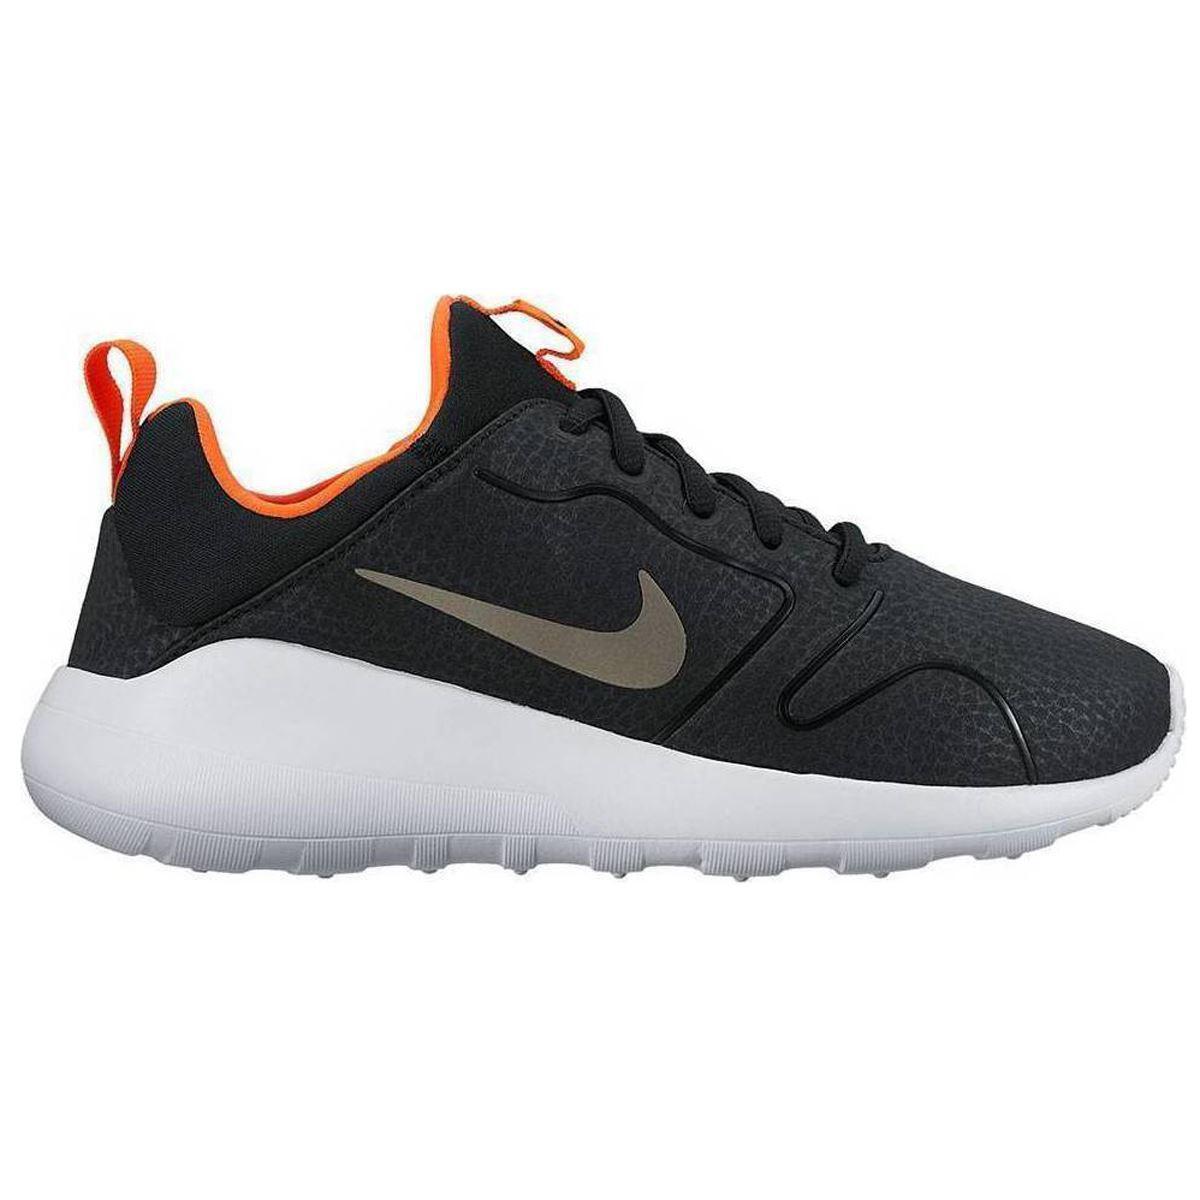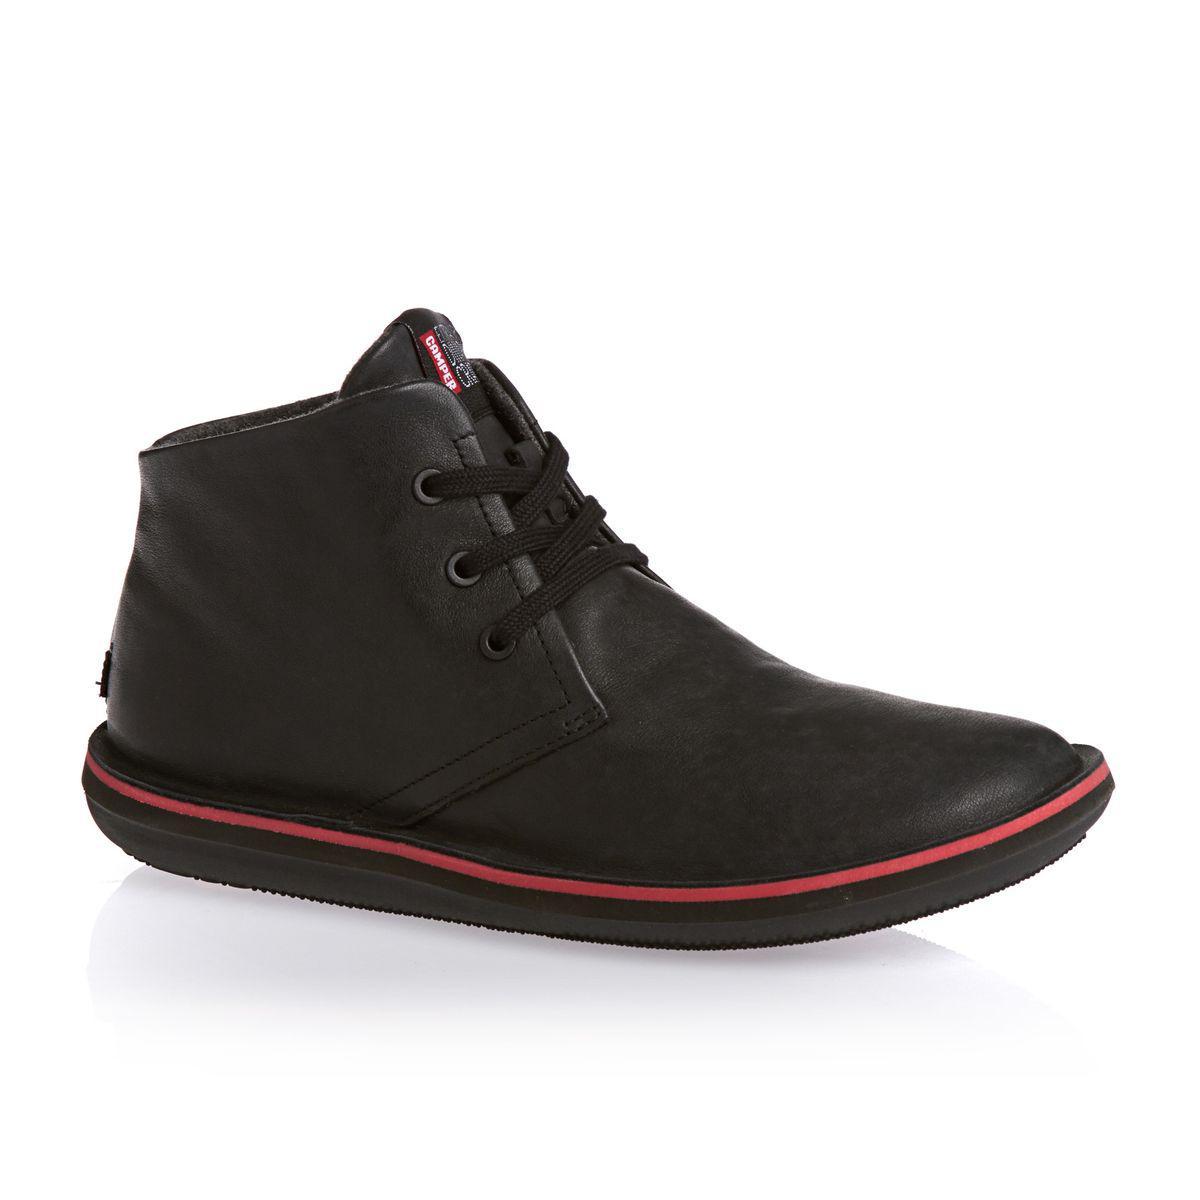The first image is the image on the left, the second image is the image on the right. Evaluate the accuracy of this statement regarding the images: "There are two shoes, both pointing in the same direction". Is it true? Answer yes or no. Yes. The first image is the image on the left, the second image is the image on the right. Analyze the images presented: Is the assertion "One of the shoes has a coral pink and white sole." valid? Answer yes or no. No. 